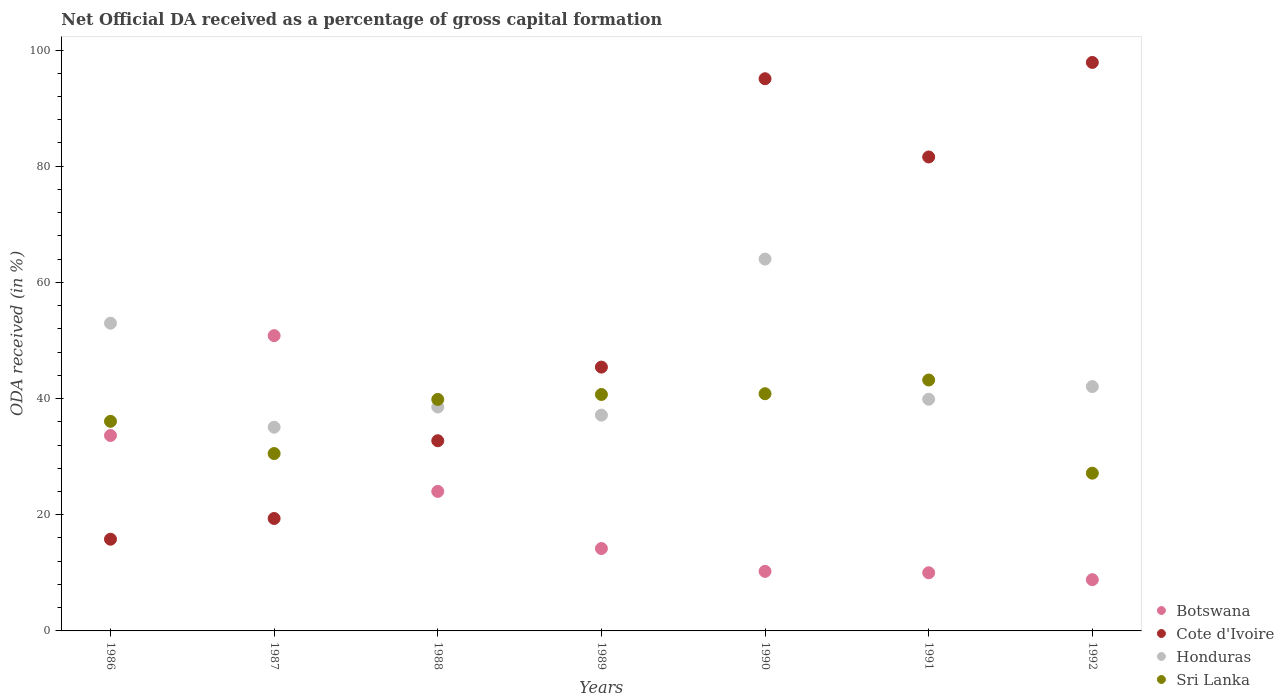What is the net ODA received in Botswana in 1990?
Make the answer very short. 10.25. Across all years, what is the maximum net ODA received in Honduras?
Keep it short and to the point. 64.01. Across all years, what is the minimum net ODA received in Sri Lanka?
Keep it short and to the point. 27.15. In which year was the net ODA received in Sri Lanka maximum?
Offer a terse response. 1991. In which year was the net ODA received in Cote d'Ivoire minimum?
Keep it short and to the point. 1986. What is the total net ODA received in Botswana in the graph?
Your answer should be compact. 151.76. What is the difference between the net ODA received in Cote d'Ivoire in 1990 and that in 1992?
Provide a short and direct response. -2.81. What is the difference between the net ODA received in Honduras in 1991 and the net ODA received in Botswana in 1988?
Offer a terse response. 15.86. What is the average net ODA received in Cote d'Ivoire per year?
Offer a very short reply. 55.4. In the year 1989, what is the difference between the net ODA received in Sri Lanka and net ODA received in Cote d'Ivoire?
Your answer should be compact. -4.71. What is the ratio of the net ODA received in Honduras in 1986 to that in 1988?
Give a very brief answer. 1.37. Is the difference between the net ODA received in Sri Lanka in 1987 and 1988 greater than the difference between the net ODA received in Cote d'Ivoire in 1987 and 1988?
Ensure brevity in your answer.  Yes. What is the difference between the highest and the second highest net ODA received in Cote d'Ivoire?
Keep it short and to the point. 2.81. What is the difference between the highest and the lowest net ODA received in Sri Lanka?
Offer a very short reply. 16.04. Is it the case that in every year, the sum of the net ODA received in Sri Lanka and net ODA received in Honduras  is greater than the sum of net ODA received in Cote d'Ivoire and net ODA received in Botswana?
Your answer should be compact. Yes. Does the net ODA received in Honduras monotonically increase over the years?
Keep it short and to the point. No. Is the net ODA received in Botswana strictly less than the net ODA received in Cote d'Ivoire over the years?
Your answer should be very brief. No. How many dotlines are there?
Keep it short and to the point. 4. What is the difference between two consecutive major ticks on the Y-axis?
Your answer should be compact. 20. Are the values on the major ticks of Y-axis written in scientific E-notation?
Make the answer very short. No. How many legend labels are there?
Offer a terse response. 4. What is the title of the graph?
Make the answer very short. Net Official DA received as a percentage of gross capital formation. What is the label or title of the Y-axis?
Your answer should be very brief. ODA received (in %). What is the ODA received (in %) of Botswana in 1986?
Keep it short and to the point. 33.64. What is the ODA received (in %) of Cote d'Ivoire in 1986?
Your answer should be very brief. 15.79. What is the ODA received (in %) of Honduras in 1986?
Offer a terse response. 52.97. What is the ODA received (in %) of Sri Lanka in 1986?
Offer a terse response. 36.08. What is the ODA received (in %) in Botswana in 1987?
Your answer should be compact. 50.83. What is the ODA received (in %) in Cote d'Ivoire in 1987?
Give a very brief answer. 19.35. What is the ODA received (in %) in Honduras in 1987?
Offer a very short reply. 35.07. What is the ODA received (in %) of Sri Lanka in 1987?
Your answer should be very brief. 30.53. What is the ODA received (in %) of Botswana in 1988?
Offer a terse response. 24.02. What is the ODA received (in %) in Cote d'Ivoire in 1988?
Keep it short and to the point. 32.74. What is the ODA received (in %) in Honduras in 1988?
Your answer should be compact. 38.54. What is the ODA received (in %) in Sri Lanka in 1988?
Keep it short and to the point. 39.85. What is the ODA received (in %) of Botswana in 1989?
Provide a succinct answer. 14.18. What is the ODA received (in %) in Cote d'Ivoire in 1989?
Your response must be concise. 45.41. What is the ODA received (in %) of Honduras in 1989?
Ensure brevity in your answer.  37.15. What is the ODA received (in %) of Sri Lanka in 1989?
Offer a very short reply. 40.7. What is the ODA received (in %) of Botswana in 1990?
Offer a very short reply. 10.25. What is the ODA received (in %) in Cote d'Ivoire in 1990?
Provide a short and direct response. 95.05. What is the ODA received (in %) of Honduras in 1990?
Offer a terse response. 64.01. What is the ODA received (in %) in Sri Lanka in 1990?
Provide a succinct answer. 40.83. What is the ODA received (in %) of Botswana in 1991?
Your response must be concise. 10.01. What is the ODA received (in %) in Cote d'Ivoire in 1991?
Your answer should be very brief. 81.59. What is the ODA received (in %) of Honduras in 1991?
Your response must be concise. 39.88. What is the ODA received (in %) in Sri Lanka in 1991?
Keep it short and to the point. 43.19. What is the ODA received (in %) of Botswana in 1992?
Your answer should be compact. 8.82. What is the ODA received (in %) in Cote d'Ivoire in 1992?
Provide a short and direct response. 97.86. What is the ODA received (in %) of Honduras in 1992?
Offer a terse response. 42.06. What is the ODA received (in %) in Sri Lanka in 1992?
Provide a succinct answer. 27.15. Across all years, what is the maximum ODA received (in %) of Botswana?
Ensure brevity in your answer.  50.83. Across all years, what is the maximum ODA received (in %) in Cote d'Ivoire?
Your answer should be very brief. 97.86. Across all years, what is the maximum ODA received (in %) of Honduras?
Your response must be concise. 64.01. Across all years, what is the maximum ODA received (in %) of Sri Lanka?
Ensure brevity in your answer.  43.19. Across all years, what is the minimum ODA received (in %) in Botswana?
Ensure brevity in your answer.  8.82. Across all years, what is the minimum ODA received (in %) in Cote d'Ivoire?
Make the answer very short. 15.79. Across all years, what is the minimum ODA received (in %) in Honduras?
Offer a very short reply. 35.07. Across all years, what is the minimum ODA received (in %) of Sri Lanka?
Your answer should be very brief. 27.15. What is the total ODA received (in %) in Botswana in the graph?
Offer a terse response. 151.76. What is the total ODA received (in %) of Cote d'Ivoire in the graph?
Your answer should be very brief. 387.8. What is the total ODA received (in %) in Honduras in the graph?
Offer a terse response. 309.69. What is the total ODA received (in %) of Sri Lanka in the graph?
Your response must be concise. 258.34. What is the difference between the ODA received (in %) in Botswana in 1986 and that in 1987?
Your answer should be very brief. -17.19. What is the difference between the ODA received (in %) of Cote d'Ivoire in 1986 and that in 1987?
Make the answer very short. -3.57. What is the difference between the ODA received (in %) in Honduras in 1986 and that in 1987?
Give a very brief answer. 17.91. What is the difference between the ODA received (in %) in Sri Lanka in 1986 and that in 1987?
Your answer should be very brief. 5.54. What is the difference between the ODA received (in %) of Botswana in 1986 and that in 1988?
Ensure brevity in your answer.  9.62. What is the difference between the ODA received (in %) of Cote d'Ivoire in 1986 and that in 1988?
Make the answer very short. -16.95. What is the difference between the ODA received (in %) in Honduras in 1986 and that in 1988?
Offer a terse response. 14.43. What is the difference between the ODA received (in %) in Sri Lanka in 1986 and that in 1988?
Your answer should be very brief. -3.77. What is the difference between the ODA received (in %) in Botswana in 1986 and that in 1989?
Your answer should be compact. 19.46. What is the difference between the ODA received (in %) of Cote d'Ivoire in 1986 and that in 1989?
Give a very brief answer. -29.63. What is the difference between the ODA received (in %) of Honduras in 1986 and that in 1989?
Ensure brevity in your answer.  15.83. What is the difference between the ODA received (in %) in Sri Lanka in 1986 and that in 1989?
Ensure brevity in your answer.  -4.62. What is the difference between the ODA received (in %) of Botswana in 1986 and that in 1990?
Ensure brevity in your answer.  23.39. What is the difference between the ODA received (in %) of Cote d'Ivoire in 1986 and that in 1990?
Make the answer very short. -79.27. What is the difference between the ODA received (in %) of Honduras in 1986 and that in 1990?
Give a very brief answer. -11.04. What is the difference between the ODA received (in %) in Sri Lanka in 1986 and that in 1990?
Your answer should be compact. -4.75. What is the difference between the ODA received (in %) of Botswana in 1986 and that in 1991?
Ensure brevity in your answer.  23.63. What is the difference between the ODA received (in %) in Cote d'Ivoire in 1986 and that in 1991?
Offer a very short reply. -65.8. What is the difference between the ODA received (in %) in Honduras in 1986 and that in 1991?
Your answer should be very brief. 13.09. What is the difference between the ODA received (in %) of Sri Lanka in 1986 and that in 1991?
Ensure brevity in your answer.  -7.11. What is the difference between the ODA received (in %) in Botswana in 1986 and that in 1992?
Give a very brief answer. 24.82. What is the difference between the ODA received (in %) in Cote d'Ivoire in 1986 and that in 1992?
Ensure brevity in your answer.  -82.07. What is the difference between the ODA received (in %) of Honduras in 1986 and that in 1992?
Offer a terse response. 10.92. What is the difference between the ODA received (in %) of Sri Lanka in 1986 and that in 1992?
Offer a terse response. 8.92. What is the difference between the ODA received (in %) of Botswana in 1987 and that in 1988?
Provide a short and direct response. 26.81. What is the difference between the ODA received (in %) of Cote d'Ivoire in 1987 and that in 1988?
Provide a short and direct response. -13.38. What is the difference between the ODA received (in %) in Honduras in 1987 and that in 1988?
Give a very brief answer. -3.48. What is the difference between the ODA received (in %) in Sri Lanka in 1987 and that in 1988?
Offer a very short reply. -9.32. What is the difference between the ODA received (in %) in Botswana in 1987 and that in 1989?
Your answer should be very brief. 36.65. What is the difference between the ODA received (in %) in Cote d'Ivoire in 1987 and that in 1989?
Provide a short and direct response. -26.06. What is the difference between the ODA received (in %) in Honduras in 1987 and that in 1989?
Offer a terse response. -2.08. What is the difference between the ODA received (in %) in Sri Lanka in 1987 and that in 1989?
Give a very brief answer. -10.17. What is the difference between the ODA received (in %) of Botswana in 1987 and that in 1990?
Give a very brief answer. 40.58. What is the difference between the ODA received (in %) in Cote d'Ivoire in 1987 and that in 1990?
Your response must be concise. -75.7. What is the difference between the ODA received (in %) of Honduras in 1987 and that in 1990?
Your response must be concise. -28.95. What is the difference between the ODA received (in %) of Sri Lanka in 1987 and that in 1990?
Keep it short and to the point. -10.3. What is the difference between the ODA received (in %) of Botswana in 1987 and that in 1991?
Make the answer very short. 40.82. What is the difference between the ODA received (in %) of Cote d'Ivoire in 1987 and that in 1991?
Offer a very short reply. -62.23. What is the difference between the ODA received (in %) of Honduras in 1987 and that in 1991?
Ensure brevity in your answer.  -4.82. What is the difference between the ODA received (in %) in Sri Lanka in 1987 and that in 1991?
Offer a very short reply. -12.66. What is the difference between the ODA received (in %) in Botswana in 1987 and that in 1992?
Make the answer very short. 42.01. What is the difference between the ODA received (in %) of Cote d'Ivoire in 1987 and that in 1992?
Keep it short and to the point. -78.51. What is the difference between the ODA received (in %) in Honduras in 1987 and that in 1992?
Keep it short and to the point. -6.99. What is the difference between the ODA received (in %) of Sri Lanka in 1987 and that in 1992?
Provide a short and direct response. 3.38. What is the difference between the ODA received (in %) of Botswana in 1988 and that in 1989?
Provide a short and direct response. 9.83. What is the difference between the ODA received (in %) of Cote d'Ivoire in 1988 and that in 1989?
Keep it short and to the point. -12.68. What is the difference between the ODA received (in %) in Honduras in 1988 and that in 1989?
Give a very brief answer. 1.4. What is the difference between the ODA received (in %) of Sri Lanka in 1988 and that in 1989?
Keep it short and to the point. -0.85. What is the difference between the ODA received (in %) of Botswana in 1988 and that in 1990?
Provide a succinct answer. 13.77. What is the difference between the ODA received (in %) of Cote d'Ivoire in 1988 and that in 1990?
Provide a short and direct response. -62.32. What is the difference between the ODA received (in %) of Honduras in 1988 and that in 1990?
Give a very brief answer. -25.47. What is the difference between the ODA received (in %) in Sri Lanka in 1988 and that in 1990?
Provide a succinct answer. -0.98. What is the difference between the ODA received (in %) in Botswana in 1988 and that in 1991?
Your response must be concise. 14.01. What is the difference between the ODA received (in %) of Cote d'Ivoire in 1988 and that in 1991?
Keep it short and to the point. -48.85. What is the difference between the ODA received (in %) in Honduras in 1988 and that in 1991?
Give a very brief answer. -1.34. What is the difference between the ODA received (in %) of Sri Lanka in 1988 and that in 1991?
Your answer should be very brief. -3.34. What is the difference between the ODA received (in %) in Botswana in 1988 and that in 1992?
Ensure brevity in your answer.  15.2. What is the difference between the ODA received (in %) in Cote d'Ivoire in 1988 and that in 1992?
Your answer should be very brief. -65.12. What is the difference between the ODA received (in %) of Honduras in 1988 and that in 1992?
Provide a succinct answer. -3.51. What is the difference between the ODA received (in %) in Sri Lanka in 1988 and that in 1992?
Provide a short and direct response. 12.7. What is the difference between the ODA received (in %) of Botswana in 1989 and that in 1990?
Offer a terse response. 3.93. What is the difference between the ODA received (in %) of Cote d'Ivoire in 1989 and that in 1990?
Your response must be concise. -49.64. What is the difference between the ODA received (in %) in Honduras in 1989 and that in 1990?
Make the answer very short. -26.86. What is the difference between the ODA received (in %) in Sri Lanka in 1989 and that in 1990?
Offer a very short reply. -0.13. What is the difference between the ODA received (in %) of Botswana in 1989 and that in 1991?
Your response must be concise. 4.17. What is the difference between the ODA received (in %) of Cote d'Ivoire in 1989 and that in 1991?
Make the answer very short. -36.17. What is the difference between the ODA received (in %) of Honduras in 1989 and that in 1991?
Provide a short and direct response. -2.73. What is the difference between the ODA received (in %) of Sri Lanka in 1989 and that in 1991?
Offer a very short reply. -2.49. What is the difference between the ODA received (in %) in Botswana in 1989 and that in 1992?
Give a very brief answer. 5.36. What is the difference between the ODA received (in %) of Cote d'Ivoire in 1989 and that in 1992?
Offer a very short reply. -52.45. What is the difference between the ODA received (in %) of Honduras in 1989 and that in 1992?
Offer a very short reply. -4.91. What is the difference between the ODA received (in %) in Sri Lanka in 1989 and that in 1992?
Keep it short and to the point. 13.55. What is the difference between the ODA received (in %) of Botswana in 1990 and that in 1991?
Make the answer very short. 0.24. What is the difference between the ODA received (in %) of Cote d'Ivoire in 1990 and that in 1991?
Your answer should be compact. 13.47. What is the difference between the ODA received (in %) of Honduras in 1990 and that in 1991?
Your answer should be compact. 24.13. What is the difference between the ODA received (in %) in Sri Lanka in 1990 and that in 1991?
Give a very brief answer. -2.36. What is the difference between the ODA received (in %) in Botswana in 1990 and that in 1992?
Provide a succinct answer. 1.43. What is the difference between the ODA received (in %) in Cote d'Ivoire in 1990 and that in 1992?
Make the answer very short. -2.81. What is the difference between the ODA received (in %) in Honduras in 1990 and that in 1992?
Keep it short and to the point. 21.95. What is the difference between the ODA received (in %) of Sri Lanka in 1990 and that in 1992?
Give a very brief answer. 13.68. What is the difference between the ODA received (in %) in Botswana in 1991 and that in 1992?
Offer a very short reply. 1.19. What is the difference between the ODA received (in %) in Cote d'Ivoire in 1991 and that in 1992?
Ensure brevity in your answer.  -16.27. What is the difference between the ODA received (in %) in Honduras in 1991 and that in 1992?
Provide a succinct answer. -2.18. What is the difference between the ODA received (in %) in Sri Lanka in 1991 and that in 1992?
Offer a terse response. 16.04. What is the difference between the ODA received (in %) of Botswana in 1986 and the ODA received (in %) of Cote d'Ivoire in 1987?
Ensure brevity in your answer.  14.29. What is the difference between the ODA received (in %) in Botswana in 1986 and the ODA received (in %) in Honduras in 1987?
Your response must be concise. -1.42. What is the difference between the ODA received (in %) of Botswana in 1986 and the ODA received (in %) of Sri Lanka in 1987?
Give a very brief answer. 3.11. What is the difference between the ODA received (in %) in Cote d'Ivoire in 1986 and the ODA received (in %) in Honduras in 1987?
Your response must be concise. -19.28. What is the difference between the ODA received (in %) of Cote d'Ivoire in 1986 and the ODA received (in %) of Sri Lanka in 1987?
Your response must be concise. -14.75. What is the difference between the ODA received (in %) in Honduras in 1986 and the ODA received (in %) in Sri Lanka in 1987?
Keep it short and to the point. 22.44. What is the difference between the ODA received (in %) in Botswana in 1986 and the ODA received (in %) in Cote d'Ivoire in 1988?
Give a very brief answer. 0.9. What is the difference between the ODA received (in %) of Botswana in 1986 and the ODA received (in %) of Honduras in 1988?
Provide a succinct answer. -4.9. What is the difference between the ODA received (in %) of Botswana in 1986 and the ODA received (in %) of Sri Lanka in 1988?
Make the answer very short. -6.21. What is the difference between the ODA received (in %) of Cote d'Ivoire in 1986 and the ODA received (in %) of Honduras in 1988?
Make the answer very short. -22.76. What is the difference between the ODA received (in %) of Cote d'Ivoire in 1986 and the ODA received (in %) of Sri Lanka in 1988?
Offer a very short reply. -24.06. What is the difference between the ODA received (in %) in Honduras in 1986 and the ODA received (in %) in Sri Lanka in 1988?
Your answer should be very brief. 13.12. What is the difference between the ODA received (in %) in Botswana in 1986 and the ODA received (in %) in Cote d'Ivoire in 1989?
Ensure brevity in your answer.  -11.77. What is the difference between the ODA received (in %) of Botswana in 1986 and the ODA received (in %) of Honduras in 1989?
Ensure brevity in your answer.  -3.51. What is the difference between the ODA received (in %) of Botswana in 1986 and the ODA received (in %) of Sri Lanka in 1989?
Ensure brevity in your answer.  -7.06. What is the difference between the ODA received (in %) in Cote d'Ivoire in 1986 and the ODA received (in %) in Honduras in 1989?
Your response must be concise. -21.36. What is the difference between the ODA received (in %) in Cote d'Ivoire in 1986 and the ODA received (in %) in Sri Lanka in 1989?
Offer a terse response. -24.91. What is the difference between the ODA received (in %) of Honduras in 1986 and the ODA received (in %) of Sri Lanka in 1989?
Offer a terse response. 12.27. What is the difference between the ODA received (in %) in Botswana in 1986 and the ODA received (in %) in Cote d'Ivoire in 1990?
Ensure brevity in your answer.  -61.41. What is the difference between the ODA received (in %) of Botswana in 1986 and the ODA received (in %) of Honduras in 1990?
Make the answer very short. -30.37. What is the difference between the ODA received (in %) of Botswana in 1986 and the ODA received (in %) of Sri Lanka in 1990?
Ensure brevity in your answer.  -7.19. What is the difference between the ODA received (in %) of Cote d'Ivoire in 1986 and the ODA received (in %) of Honduras in 1990?
Your response must be concise. -48.22. What is the difference between the ODA received (in %) in Cote d'Ivoire in 1986 and the ODA received (in %) in Sri Lanka in 1990?
Your answer should be compact. -25.05. What is the difference between the ODA received (in %) in Honduras in 1986 and the ODA received (in %) in Sri Lanka in 1990?
Your answer should be very brief. 12.14. What is the difference between the ODA received (in %) of Botswana in 1986 and the ODA received (in %) of Cote d'Ivoire in 1991?
Provide a succinct answer. -47.95. What is the difference between the ODA received (in %) in Botswana in 1986 and the ODA received (in %) in Honduras in 1991?
Provide a succinct answer. -6.24. What is the difference between the ODA received (in %) in Botswana in 1986 and the ODA received (in %) in Sri Lanka in 1991?
Offer a very short reply. -9.55. What is the difference between the ODA received (in %) in Cote d'Ivoire in 1986 and the ODA received (in %) in Honduras in 1991?
Offer a very short reply. -24.09. What is the difference between the ODA received (in %) in Cote d'Ivoire in 1986 and the ODA received (in %) in Sri Lanka in 1991?
Your answer should be compact. -27.41. What is the difference between the ODA received (in %) in Honduras in 1986 and the ODA received (in %) in Sri Lanka in 1991?
Provide a succinct answer. 9.78. What is the difference between the ODA received (in %) of Botswana in 1986 and the ODA received (in %) of Cote d'Ivoire in 1992?
Keep it short and to the point. -64.22. What is the difference between the ODA received (in %) of Botswana in 1986 and the ODA received (in %) of Honduras in 1992?
Your answer should be very brief. -8.42. What is the difference between the ODA received (in %) of Botswana in 1986 and the ODA received (in %) of Sri Lanka in 1992?
Your answer should be very brief. 6.49. What is the difference between the ODA received (in %) in Cote d'Ivoire in 1986 and the ODA received (in %) in Honduras in 1992?
Offer a terse response. -26.27. What is the difference between the ODA received (in %) in Cote d'Ivoire in 1986 and the ODA received (in %) in Sri Lanka in 1992?
Your response must be concise. -11.37. What is the difference between the ODA received (in %) of Honduras in 1986 and the ODA received (in %) of Sri Lanka in 1992?
Provide a short and direct response. 25.82. What is the difference between the ODA received (in %) in Botswana in 1987 and the ODA received (in %) in Cote d'Ivoire in 1988?
Ensure brevity in your answer.  18.09. What is the difference between the ODA received (in %) of Botswana in 1987 and the ODA received (in %) of Honduras in 1988?
Provide a succinct answer. 12.28. What is the difference between the ODA received (in %) of Botswana in 1987 and the ODA received (in %) of Sri Lanka in 1988?
Your answer should be very brief. 10.98. What is the difference between the ODA received (in %) of Cote d'Ivoire in 1987 and the ODA received (in %) of Honduras in 1988?
Your answer should be compact. -19.19. What is the difference between the ODA received (in %) in Cote d'Ivoire in 1987 and the ODA received (in %) in Sri Lanka in 1988?
Your answer should be very brief. -20.5. What is the difference between the ODA received (in %) of Honduras in 1987 and the ODA received (in %) of Sri Lanka in 1988?
Ensure brevity in your answer.  -4.78. What is the difference between the ODA received (in %) of Botswana in 1987 and the ODA received (in %) of Cote d'Ivoire in 1989?
Provide a short and direct response. 5.41. What is the difference between the ODA received (in %) in Botswana in 1987 and the ODA received (in %) in Honduras in 1989?
Give a very brief answer. 13.68. What is the difference between the ODA received (in %) of Botswana in 1987 and the ODA received (in %) of Sri Lanka in 1989?
Offer a very short reply. 10.13. What is the difference between the ODA received (in %) of Cote d'Ivoire in 1987 and the ODA received (in %) of Honduras in 1989?
Give a very brief answer. -17.79. What is the difference between the ODA received (in %) in Cote d'Ivoire in 1987 and the ODA received (in %) in Sri Lanka in 1989?
Your answer should be compact. -21.35. What is the difference between the ODA received (in %) of Honduras in 1987 and the ODA received (in %) of Sri Lanka in 1989?
Offer a terse response. -5.63. What is the difference between the ODA received (in %) of Botswana in 1987 and the ODA received (in %) of Cote d'Ivoire in 1990?
Provide a succinct answer. -44.22. What is the difference between the ODA received (in %) of Botswana in 1987 and the ODA received (in %) of Honduras in 1990?
Your answer should be very brief. -13.18. What is the difference between the ODA received (in %) in Botswana in 1987 and the ODA received (in %) in Sri Lanka in 1990?
Offer a very short reply. 10. What is the difference between the ODA received (in %) of Cote d'Ivoire in 1987 and the ODA received (in %) of Honduras in 1990?
Your answer should be very brief. -44.66. What is the difference between the ODA received (in %) of Cote d'Ivoire in 1987 and the ODA received (in %) of Sri Lanka in 1990?
Your response must be concise. -21.48. What is the difference between the ODA received (in %) of Honduras in 1987 and the ODA received (in %) of Sri Lanka in 1990?
Provide a short and direct response. -5.77. What is the difference between the ODA received (in %) of Botswana in 1987 and the ODA received (in %) of Cote d'Ivoire in 1991?
Your answer should be very brief. -30.76. What is the difference between the ODA received (in %) in Botswana in 1987 and the ODA received (in %) in Honduras in 1991?
Make the answer very short. 10.95. What is the difference between the ODA received (in %) of Botswana in 1987 and the ODA received (in %) of Sri Lanka in 1991?
Your answer should be compact. 7.64. What is the difference between the ODA received (in %) in Cote d'Ivoire in 1987 and the ODA received (in %) in Honduras in 1991?
Offer a terse response. -20.53. What is the difference between the ODA received (in %) in Cote d'Ivoire in 1987 and the ODA received (in %) in Sri Lanka in 1991?
Your response must be concise. -23.84. What is the difference between the ODA received (in %) of Honduras in 1987 and the ODA received (in %) of Sri Lanka in 1991?
Make the answer very short. -8.13. What is the difference between the ODA received (in %) of Botswana in 1987 and the ODA received (in %) of Cote d'Ivoire in 1992?
Your response must be concise. -47.03. What is the difference between the ODA received (in %) in Botswana in 1987 and the ODA received (in %) in Honduras in 1992?
Provide a short and direct response. 8.77. What is the difference between the ODA received (in %) of Botswana in 1987 and the ODA received (in %) of Sri Lanka in 1992?
Your response must be concise. 23.67. What is the difference between the ODA received (in %) of Cote d'Ivoire in 1987 and the ODA received (in %) of Honduras in 1992?
Give a very brief answer. -22.7. What is the difference between the ODA received (in %) in Cote d'Ivoire in 1987 and the ODA received (in %) in Sri Lanka in 1992?
Offer a terse response. -7.8. What is the difference between the ODA received (in %) in Honduras in 1987 and the ODA received (in %) in Sri Lanka in 1992?
Offer a terse response. 7.91. What is the difference between the ODA received (in %) of Botswana in 1988 and the ODA received (in %) of Cote d'Ivoire in 1989?
Give a very brief answer. -21.4. What is the difference between the ODA received (in %) in Botswana in 1988 and the ODA received (in %) in Honduras in 1989?
Keep it short and to the point. -13.13. What is the difference between the ODA received (in %) in Botswana in 1988 and the ODA received (in %) in Sri Lanka in 1989?
Your answer should be very brief. -16.68. What is the difference between the ODA received (in %) of Cote d'Ivoire in 1988 and the ODA received (in %) of Honduras in 1989?
Provide a short and direct response. -4.41. What is the difference between the ODA received (in %) of Cote d'Ivoire in 1988 and the ODA received (in %) of Sri Lanka in 1989?
Your answer should be compact. -7.96. What is the difference between the ODA received (in %) in Honduras in 1988 and the ODA received (in %) in Sri Lanka in 1989?
Offer a terse response. -2.16. What is the difference between the ODA received (in %) of Botswana in 1988 and the ODA received (in %) of Cote d'Ivoire in 1990?
Make the answer very short. -71.04. What is the difference between the ODA received (in %) in Botswana in 1988 and the ODA received (in %) in Honduras in 1990?
Provide a short and direct response. -39.99. What is the difference between the ODA received (in %) of Botswana in 1988 and the ODA received (in %) of Sri Lanka in 1990?
Provide a succinct answer. -16.82. What is the difference between the ODA received (in %) in Cote d'Ivoire in 1988 and the ODA received (in %) in Honduras in 1990?
Ensure brevity in your answer.  -31.27. What is the difference between the ODA received (in %) in Cote d'Ivoire in 1988 and the ODA received (in %) in Sri Lanka in 1990?
Ensure brevity in your answer.  -8.09. What is the difference between the ODA received (in %) of Honduras in 1988 and the ODA received (in %) of Sri Lanka in 1990?
Your answer should be very brief. -2.29. What is the difference between the ODA received (in %) of Botswana in 1988 and the ODA received (in %) of Cote d'Ivoire in 1991?
Make the answer very short. -57.57. What is the difference between the ODA received (in %) in Botswana in 1988 and the ODA received (in %) in Honduras in 1991?
Provide a short and direct response. -15.86. What is the difference between the ODA received (in %) in Botswana in 1988 and the ODA received (in %) in Sri Lanka in 1991?
Offer a very short reply. -19.18. What is the difference between the ODA received (in %) of Cote d'Ivoire in 1988 and the ODA received (in %) of Honduras in 1991?
Keep it short and to the point. -7.14. What is the difference between the ODA received (in %) in Cote d'Ivoire in 1988 and the ODA received (in %) in Sri Lanka in 1991?
Your answer should be compact. -10.45. What is the difference between the ODA received (in %) of Honduras in 1988 and the ODA received (in %) of Sri Lanka in 1991?
Give a very brief answer. -4.65. What is the difference between the ODA received (in %) of Botswana in 1988 and the ODA received (in %) of Cote d'Ivoire in 1992?
Provide a succinct answer. -73.84. What is the difference between the ODA received (in %) of Botswana in 1988 and the ODA received (in %) of Honduras in 1992?
Offer a very short reply. -18.04. What is the difference between the ODA received (in %) of Botswana in 1988 and the ODA received (in %) of Sri Lanka in 1992?
Provide a short and direct response. -3.14. What is the difference between the ODA received (in %) of Cote d'Ivoire in 1988 and the ODA received (in %) of Honduras in 1992?
Provide a short and direct response. -9.32. What is the difference between the ODA received (in %) of Cote d'Ivoire in 1988 and the ODA received (in %) of Sri Lanka in 1992?
Provide a succinct answer. 5.58. What is the difference between the ODA received (in %) of Honduras in 1988 and the ODA received (in %) of Sri Lanka in 1992?
Ensure brevity in your answer.  11.39. What is the difference between the ODA received (in %) in Botswana in 1989 and the ODA received (in %) in Cote d'Ivoire in 1990?
Give a very brief answer. -80.87. What is the difference between the ODA received (in %) in Botswana in 1989 and the ODA received (in %) in Honduras in 1990?
Offer a very short reply. -49.83. What is the difference between the ODA received (in %) of Botswana in 1989 and the ODA received (in %) of Sri Lanka in 1990?
Keep it short and to the point. -26.65. What is the difference between the ODA received (in %) of Cote d'Ivoire in 1989 and the ODA received (in %) of Honduras in 1990?
Your response must be concise. -18.6. What is the difference between the ODA received (in %) in Cote d'Ivoire in 1989 and the ODA received (in %) in Sri Lanka in 1990?
Ensure brevity in your answer.  4.58. What is the difference between the ODA received (in %) in Honduras in 1989 and the ODA received (in %) in Sri Lanka in 1990?
Your response must be concise. -3.68. What is the difference between the ODA received (in %) in Botswana in 1989 and the ODA received (in %) in Cote d'Ivoire in 1991?
Provide a short and direct response. -67.4. What is the difference between the ODA received (in %) in Botswana in 1989 and the ODA received (in %) in Honduras in 1991?
Your response must be concise. -25.7. What is the difference between the ODA received (in %) of Botswana in 1989 and the ODA received (in %) of Sri Lanka in 1991?
Offer a terse response. -29.01. What is the difference between the ODA received (in %) in Cote d'Ivoire in 1989 and the ODA received (in %) in Honduras in 1991?
Ensure brevity in your answer.  5.53. What is the difference between the ODA received (in %) in Cote d'Ivoire in 1989 and the ODA received (in %) in Sri Lanka in 1991?
Your response must be concise. 2.22. What is the difference between the ODA received (in %) in Honduras in 1989 and the ODA received (in %) in Sri Lanka in 1991?
Ensure brevity in your answer.  -6.04. What is the difference between the ODA received (in %) in Botswana in 1989 and the ODA received (in %) in Cote d'Ivoire in 1992?
Offer a very short reply. -83.68. What is the difference between the ODA received (in %) in Botswana in 1989 and the ODA received (in %) in Honduras in 1992?
Provide a short and direct response. -27.87. What is the difference between the ODA received (in %) in Botswana in 1989 and the ODA received (in %) in Sri Lanka in 1992?
Give a very brief answer. -12.97. What is the difference between the ODA received (in %) of Cote d'Ivoire in 1989 and the ODA received (in %) of Honduras in 1992?
Ensure brevity in your answer.  3.36. What is the difference between the ODA received (in %) of Cote d'Ivoire in 1989 and the ODA received (in %) of Sri Lanka in 1992?
Offer a very short reply. 18.26. What is the difference between the ODA received (in %) of Honduras in 1989 and the ODA received (in %) of Sri Lanka in 1992?
Ensure brevity in your answer.  9.99. What is the difference between the ODA received (in %) of Botswana in 1990 and the ODA received (in %) of Cote d'Ivoire in 1991?
Provide a short and direct response. -71.34. What is the difference between the ODA received (in %) of Botswana in 1990 and the ODA received (in %) of Honduras in 1991?
Offer a very short reply. -29.63. What is the difference between the ODA received (in %) of Botswana in 1990 and the ODA received (in %) of Sri Lanka in 1991?
Ensure brevity in your answer.  -32.94. What is the difference between the ODA received (in %) in Cote d'Ivoire in 1990 and the ODA received (in %) in Honduras in 1991?
Your answer should be very brief. 55.17. What is the difference between the ODA received (in %) in Cote d'Ivoire in 1990 and the ODA received (in %) in Sri Lanka in 1991?
Provide a short and direct response. 51.86. What is the difference between the ODA received (in %) in Honduras in 1990 and the ODA received (in %) in Sri Lanka in 1991?
Make the answer very short. 20.82. What is the difference between the ODA received (in %) of Botswana in 1990 and the ODA received (in %) of Cote d'Ivoire in 1992?
Your response must be concise. -87.61. What is the difference between the ODA received (in %) of Botswana in 1990 and the ODA received (in %) of Honduras in 1992?
Provide a short and direct response. -31.81. What is the difference between the ODA received (in %) of Botswana in 1990 and the ODA received (in %) of Sri Lanka in 1992?
Keep it short and to the point. -16.9. What is the difference between the ODA received (in %) of Cote d'Ivoire in 1990 and the ODA received (in %) of Honduras in 1992?
Your answer should be compact. 53. What is the difference between the ODA received (in %) in Cote d'Ivoire in 1990 and the ODA received (in %) in Sri Lanka in 1992?
Keep it short and to the point. 67.9. What is the difference between the ODA received (in %) in Honduras in 1990 and the ODA received (in %) in Sri Lanka in 1992?
Make the answer very short. 36.86. What is the difference between the ODA received (in %) of Botswana in 1991 and the ODA received (in %) of Cote d'Ivoire in 1992?
Make the answer very short. -87.85. What is the difference between the ODA received (in %) in Botswana in 1991 and the ODA received (in %) in Honduras in 1992?
Offer a terse response. -32.05. What is the difference between the ODA received (in %) in Botswana in 1991 and the ODA received (in %) in Sri Lanka in 1992?
Offer a very short reply. -17.14. What is the difference between the ODA received (in %) of Cote d'Ivoire in 1991 and the ODA received (in %) of Honduras in 1992?
Provide a succinct answer. 39.53. What is the difference between the ODA received (in %) in Cote d'Ivoire in 1991 and the ODA received (in %) in Sri Lanka in 1992?
Provide a short and direct response. 54.43. What is the difference between the ODA received (in %) in Honduras in 1991 and the ODA received (in %) in Sri Lanka in 1992?
Your response must be concise. 12.73. What is the average ODA received (in %) of Botswana per year?
Your response must be concise. 21.68. What is the average ODA received (in %) in Cote d'Ivoire per year?
Your answer should be compact. 55.4. What is the average ODA received (in %) in Honduras per year?
Your answer should be very brief. 44.24. What is the average ODA received (in %) of Sri Lanka per year?
Your response must be concise. 36.91. In the year 1986, what is the difference between the ODA received (in %) of Botswana and ODA received (in %) of Cote d'Ivoire?
Make the answer very short. 17.86. In the year 1986, what is the difference between the ODA received (in %) in Botswana and ODA received (in %) in Honduras?
Make the answer very short. -19.33. In the year 1986, what is the difference between the ODA received (in %) in Botswana and ODA received (in %) in Sri Lanka?
Keep it short and to the point. -2.44. In the year 1986, what is the difference between the ODA received (in %) of Cote d'Ivoire and ODA received (in %) of Honduras?
Ensure brevity in your answer.  -37.19. In the year 1986, what is the difference between the ODA received (in %) of Cote d'Ivoire and ODA received (in %) of Sri Lanka?
Your answer should be very brief. -20.29. In the year 1986, what is the difference between the ODA received (in %) in Honduras and ODA received (in %) in Sri Lanka?
Your answer should be very brief. 16.9. In the year 1987, what is the difference between the ODA received (in %) of Botswana and ODA received (in %) of Cote d'Ivoire?
Give a very brief answer. 31.48. In the year 1987, what is the difference between the ODA received (in %) of Botswana and ODA received (in %) of Honduras?
Offer a terse response. 15.76. In the year 1987, what is the difference between the ODA received (in %) in Botswana and ODA received (in %) in Sri Lanka?
Your answer should be compact. 20.3. In the year 1987, what is the difference between the ODA received (in %) of Cote d'Ivoire and ODA received (in %) of Honduras?
Offer a terse response. -15.71. In the year 1987, what is the difference between the ODA received (in %) of Cote d'Ivoire and ODA received (in %) of Sri Lanka?
Keep it short and to the point. -11.18. In the year 1987, what is the difference between the ODA received (in %) of Honduras and ODA received (in %) of Sri Lanka?
Make the answer very short. 4.53. In the year 1988, what is the difference between the ODA received (in %) in Botswana and ODA received (in %) in Cote d'Ivoire?
Provide a short and direct response. -8.72. In the year 1988, what is the difference between the ODA received (in %) of Botswana and ODA received (in %) of Honduras?
Make the answer very short. -14.53. In the year 1988, what is the difference between the ODA received (in %) in Botswana and ODA received (in %) in Sri Lanka?
Provide a succinct answer. -15.83. In the year 1988, what is the difference between the ODA received (in %) in Cote d'Ivoire and ODA received (in %) in Honduras?
Your answer should be compact. -5.81. In the year 1988, what is the difference between the ODA received (in %) in Cote d'Ivoire and ODA received (in %) in Sri Lanka?
Your answer should be compact. -7.11. In the year 1988, what is the difference between the ODA received (in %) of Honduras and ODA received (in %) of Sri Lanka?
Make the answer very short. -1.31. In the year 1989, what is the difference between the ODA received (in %) of Botswana and ODA received (in %) of Cote d'Ivoire?
Your answer should be compact. -31.23. In the year 1989, what is the difference between the ODA received (in %) of Botswana and ODA received (in %) of Honduras?
Your answer should be compact. -22.96. In the year 1989, what is the difference between the ODA received (in %) of Botswana and ODA received (in %) of Sri Lanka?
Provide a succinct answer. -26.52. In the year 1989, what is the difference between the ODA received (in %) of Cote d'Ivoire and ODA received (in %) of Honduras?
Your response must be concise. 8.27. In the year 1989, what is the difference between the ODA received (in %) in Cote d'Ivoire and ODA received (in %) in Sri Lanka?
Ensure brevity in your answer.  4.71. In the year 1989, what is the difference between the ODA received (in %) of Honduras and ODA received (in %) of Sri Lanka?
Give a very brief answer. -3.55. In the year 1990, what is the difference between the ODA received (in %) in Botswana and ODA received (in %) in Cote d'Ivoire?
Offer a terse response. -84.8. In the year 1990, what is the difference between the ODA received (in %) of Botswana and ODA received (in %) of Honduras?
Your response must be concise. -53.76. In the year 1990, what is the difference between the ODA received (in %) in Botswana and ODA received (in %) in Sri Lanka?
Make the answer very short. -30.58. In the year 1990, what is the difference between the ODA received (in %) in Cote d'Ivoire and ODA received (in %) in Honduras?
Provide a succinct answer. 31.04. In the year 1990, what is the difference between the ODA received (in %) in Cote d'Ivoire and ODA received (in %) in Sri Lanka?
Your answer should be very brief. 54.22. In the year 1990, what is the difference between the ODA received (in %) of Honduras and ODA received (in %) of Sri Lanka?
Give a very brief answer. 23.18. In the year 1991, what is the difference between the ODA received (in %) of Botswana and ODA received (in %) of Cote d'Ivoire?
Provide a short and direct response. -71.58. In the year 1991, what is the difference between the ODA received (in %) in Botswana and ODA received (in %) in Honduras?
Ensure brevity in your answer.  -29.87. In the year 1991, what is the difference between the ODA received (in %) in Botswana and ODA received (in %) in Sri Lanka?
Give a very brief answer. -33.18. In the year 1991, what is the difference between the ODA received (in %) of Cote d'Ivoire and ODA received (in %) of Honduras?
Provide a short and direct response. 41.71. In the year 1991, what is the difference between the ODA received (in %) of Cote d'Ivoire and ODA received (in %) of Sri Lanka?
Give a very brief answer. 38.4. In the year 1991, what is the difference between the ODA received (in %) in Honduras and ODA received (in %) in Sri Lanka?
Ensure brevity in your answer.  -3.31. In the year 1992, what is the difference between the ODA received (in %) of Botswana and ODA received (in %) of Cote d'Ivoire?
Offer a terse response. -89.04. In the year 1992, what is the difference between the ODA received (in %) in Botswana and ODA received (in %) in Honduras?
Offer a very short reply. -33.24. In the year 1992, what is the difference between the ODA received (in %) of Botswana and ODA received (in %) of Sri Lanka?
Ensure brevity in your answer.  -18.33. In the year 1992, what is the difference between the ODA received (in %) of Cote d'Ivoire and ODA received (in %) of Honduras?
Offer a very short reply. 55.8. In the year 1992, what is the difference between the ODA received (in %) in Cote d'Ivoire and ODA received (in %) in Sri Lanka?
Offer a terse response. 70.71. In the year 1992, what is the difference between the ODA received (in %) of Honduras and ODA received (in %) of Sri Lanka?
Make the answer very short. 14.9. What is the ratio of the ODA received (in %) of Botswana in 1986 to that in 1987?
Make the answer very short. 0.66. What is the ratio of the ODA received (in %) in Cote d'Ivoire in 1986 to that in 1987?
Offer a terse response. 0.82. What is the ratio of the ODA received (in %) of Honduras in 1986 to that in 1987?
Your answer should be very brief. 1.51. What is the ratio of the ODA received (in %) in Sri Lanka in 1986 to that in 1987?
Your answer should be compact. 1.18. What is the ratio of the ODA received (in %) in Botswana in 1986 to that in 1988?
Provide a succinct answer. 1.4. What is the ratio of the ODA received (in %) of Cote d'Ivoire in 1986 to that in 1988?
Give a very brief answer. 0.48. What is the ratio of the ODA received (in %) in Honduras in 1986 to that in 1988?
Give a very brief answer. 1.37. What is the ratio of the ODA received (in %) of Sri Lanka in 1986 to that in 1988?
Ensure brevity in your answer.  0.91. What is the ratio of the ODA received (in %) of Botswana in 1986 to that in 1989?
Your response must be concise. 2.37. What is the ratio of the ODA received (in %) in Cote d'Ivoire in 1986 to that in 1989?
Provide a short and direct response. 0.35. What is the ratio of the ODA received (in %) of Honduras in 1986 to that in 1989?
Provide a succinct answer. 1.43. What is the ratio of the ODA received (in %) of Sri Lanka in 1986 to that in 1989?
Keep it short and to the point. 0.89. What is the ratio of the ODA received (in %) of Botswana in 1986 to that in 1990?
Keep it short and to the point. 3.28. What is the ratio of the ODA received (in %) in Cote d'Ivoire in 1986 to that in 1990?
Ensure brevity in your answer.  0.17. What is the ratio of the ODA received (in %) of Honduras in 1986 to that in 1990?
Your answer should be compact. 0.83. What is the ratio of the ODA received (in %) in Sri Lanka in 1986 to that in 1990?
Your answer should be compact. 0.88. What is the ratio of the ODA received (in %) in Botswana in 1986 to that in 1991?
Keep it short and to the point. 3.36. What is the ratio of the ODA received (in %) in Cote d'Ivoire in 1986 to that in 1991?
Provide a short and direct response. 0.19. What is the ratio of the ODA received (in %) of Honduras in 1986 to that in 1991?
Offer a terse response. 1.33. What is the ratio of the ODA received (in %) in Sri Lanka in 1986 to that in 1991?
Provide a succinct answer. 0.84. What is the ratio of the ODA received (in %) in Botswana in 1986 to that in 1992?
Provide a succinct answer. 3.81. What is the ratio of the ODA received (in %) in Cote d'Ivoire in 1986 to that in 1992?
Keep it short and to the point. 0.16. What is the ratio of the ODA received (in %) of Honduras in 1986 to that in 1992?
Your response must be concise. 1.26. What is the ratio of the ODA received (in %) in Sri Lanka in 1986 to that in 1992?
Make the answer very short. 1.33. What is the ratio of the ODA received (in %) of Botswana in 1987 to that in 1988?
Make the answer very short. 2.12. What is the ratio of the ODA received (in %) of Cote d'Ivoire in 1987 to that in 1988?
Offer a terse response. 0.59. What is the ratio of the ODA received (in %) of Honduras in 1987 to that in 1988?
Make the answer very short. 0.91. What is the ratio of the ODA received (in %) of Sri Lanka in 1987 to that in 1988?
Provide a short and direct response. 0.77. What is the ratio of the ODA received (in %) in Botswana in 1987 to that in 1989?
Your answer should be very brief. 3.58. What is the ratio of the ODA received (in %) of Cote d'Ivoire in 1987 to that in 1989?
Provide a succinct answer. 0.43. What is the ratio of the ODA received (in %) in Honduras in 1987 to that in 1989?
Your response must be concise. 0.94. What is the ratio of the ODA received (in %) in Sri Lanka in 1987 to that in 1989?
Provide a succinct answer. 0.75. What is the ratio of the ODA received (in %) of Botswana in 1987 to that in 1990?
Offer a terse response. 4.96. What is the ratio of the ODA received (in %) in Cote d'Ivoire in 1987 to that in 1990?
Your answer should be very brief. 0.2. What is the ratio of the ODA received (in %) in Honduras in 1987 to that in 1990?
Ensure brevity in your answer.  0.55. What is the ratio of the ODA received (in %) in Sri Lanka in 1987 to that in 1990?
Keep it short and to the point. 0.75. What is the ratio of the ODA received (in %) of Botswana in 1987 to that in 1991?
Ensure brevity in your answer.  5.08. What is the ratio of the ODA received (in %) in Cote d'Ivoire in 1987 to that in 1991?
Offer a terse response. 0.24. What is the ratio of the ODA received (in %) of Honduras in 1987 to that in 1991?
Provide a succinct answer. 0.88. What is the ratio of the ODA received (in %) in Sri Lanka in 1987 to that in 1991?
Your response must be concise. 0.71. What is the ratio of the ODA received (in %) of Botswana in 1987 to that in 1992?
Your response must be concise. 5.76. What is the ratio of the ODA received (in %) of Cote d'Ivoire in 1987 to that in 1992?
Give a very brief answer. 0.2. What is the ratio of the ODA received (in %) of Honduras in 1987 to that in 1992?
Your answer should be compact. 0.83. What is the ratio of the ODA received (in %) of Sri Lanka in 1987 to that in 1992?
Offer a very short reply. 1.12. What is the ratio of the ODA received (in %) in Botswana in 1988 to that in 1989?
Keep it short and to the point. 1.69. What is the ratio of the ODA received (in %) of Cote d'Ivoire in 1988 to that in 1989?
Provide a short and direct response. 0.72. What is the ratio of the ODA received (in %) in Honduras in 1988 to that in 1989?
Your response must be concise. 1.04. What is the ratio of the ODA received (in %) in Sri Lanka in 1988 to that in 1989?
Provide a short and direct response. 0.98. What is the ratio of the ODA received (in %) in Botswana in 1988 to that in 1990?
Keep it short and to the point. 2.34. What is the ratio of the ODA received (in %) of Cote d'Ivoire in 1988 to that in 1990?
Your response must be concise. 0.34. What is the ratio of the ODA received (in %) in Honduras in 1988 to that in 1990?
Ensure brevity in your answer.  0.6. What is the ratio of the ODA received (in %) in Sri Lanka in 1988 to that in 1990?
Make the answer very short. 0.98. What is the ratio of the ODA received (in %) in Botswana in 1988 to that in 1991?
Make the answer very short. 2.4. What is the ratio of the ODA received (in %) of Cote d'Ivoire in 1988 to that in 1991?
Ensure brevity in your answer.  0.4. What is the ratio of the ODA received (in %) in Honduras in 1988 to that in 1991?
Ensure brevity in your answer.  0.97. What is the ratio of the ODA received (in %) in Sri Lanka in 1988 to that in 1991?
Offer a very short reply. 0.92. What is the ratio of the ODA received (in %) of Botswana in 1988 to that in 1992?
Your answer should be very brief. 2.72. What is the ratio of the ODA received (in %) of Cote d'Ivoire in 1988 to that in 1992?
Make the answer very short. 0.33. What is the ratio of the ODA received (in %) in Honduras in 1988 to that in 1992?
Make the answer very short. 0.92. What is the ratio of the ODA received (in %) in Sri Lanka in 1988 to that in 1992?
Your response must be concise. 1.47. What is the ratio of the ODA received (in %) in Botswana in 1989 to that in 1990?
Your answer should be very brief. 1.38. What is the ratio of the ODA received (in %) of Cote d'Ivoire in 1989 to that in 1990?
Ensure brevity in your answer.  0.48. What is the ratio of the ODA received (in %) in Honduras in 1989 to that in 1990?
Make the answer very short. 0.58. What is the ratio of the ODA received (in %) of Botswana in 1989 to that in 1991?
Your response must be concise. 1.42. What is the ratio of the ODA received (in %) of Cote d'Ivoire in 1989 to that in 1991?
Your answer should be very brief. 0.56. What is the ratio of the ODA received (in %) in Honduras in 1989 to that in 1991?
Ensure brevity in your answer.  0.93. What is the ratio of the ODA received (in %) of Sri Lanka in 1989 to that in 1991?
Keep it short and to the point. 0.94. What is the ratio of the ODA received (in %) in Botswana in 1989 to that in 1992?
Provide a succinct answer. 1.61. What is the ratio of the ODA received (in %) in Cote d'Ivoire in 1989 to that in 1992?
Offer a very short reply. 0.46. What is the ratio of the ODA received (in %) of Honduras in 1989 to that in 1992?
Offer a very short reply. 0.88. What is the ratio of the ODA received (in %) of Sri Lanka in 1989 to that in 1992?
Your answer should be very brief. 1.5. What is the ratio of the ODA received (in %) in Botswana in 1990 to that in 1991?
Your answer should be very brief. 1.02. What is the ratio of the ODA received (in %) of Cote d'Ivoire in 1990 to that in 1991?
Your response must be concise. 1.17. What is the ratio of the ODA received (in %) of Honduras in 1990 to that in 1991?
Provide a succinct answer. 1.6. What is the ratio of the ODA received (in %) in Sri Lanka in 1990 to that in 1991?
Your answer should be compact. 0.95. What is the ratio of the ODA received (in %) of Botswana in 1990 to that in 1992?
Your answer should be compact. 1.16. What is the ratio of the ODA received (in %) of Cote d'Ivoire in 1990 to that in 1992?
Provide a succinct answer. 0.97. What is the ratio of the ODA received (in %) in Honduras in 1990 to that in 1992?
Provide a succinct answer. 1.52. What is the ratio of the ODA received (in %) of Sri Lanka in 1990 to that in 1992?
Ensure brevity in your answer.  1.5. What is the ratio of the ODA received (in %) in Botswana in 1991 to that in 1992?
Your answer should be very brief. 1.13. What is the ratio of the ODA received (in %) of Cote d'Ivoire in 1991 to that in 1992?
Your response must be concise. 0.83. What is the ratio of the ODA received (in %) in Honduras in 1991 to that in 1992?
Your answer should be very brief. 0.95. What is the ratio of the ODA received (in %) of Sri Lanka in 1991 to that in 1992?
Your answer should be very brief. 1.59. What is the difference between the highest and the second highest ODA received (in %) in Botswana?
Your response must be concise. 17.19. What is the difference between the highest and the second highest ODA received (in %) in Cote d'Ivoire?
Ensure brevity in your answer.  2.81. What is the difference between the highest and the second highest ODA received (in %) of Honduras?
Keep it short and to the point. 11.04. What is the difference between the highest and the second highest ODA received (in %) in Sri Lanka?
Provide a succinct answer. 2.36. What is the difference between the highest and the lowest ODA received (in %) of Botswana?
Keep it short and to the point. 42.01. What is the difference between the highest and the lowest ODA received (in %) of Cote d'Ivoire?
Give a very brief answer. 82.07. What is the difference between the highest and the lowest ODA received (in %) of Honduras?
Offer a very short reply. 28.95. What is the difference between the highest and the lowest ODA received (in %) of Sri Lanka?
Your answer should be very brief. 16.04. 